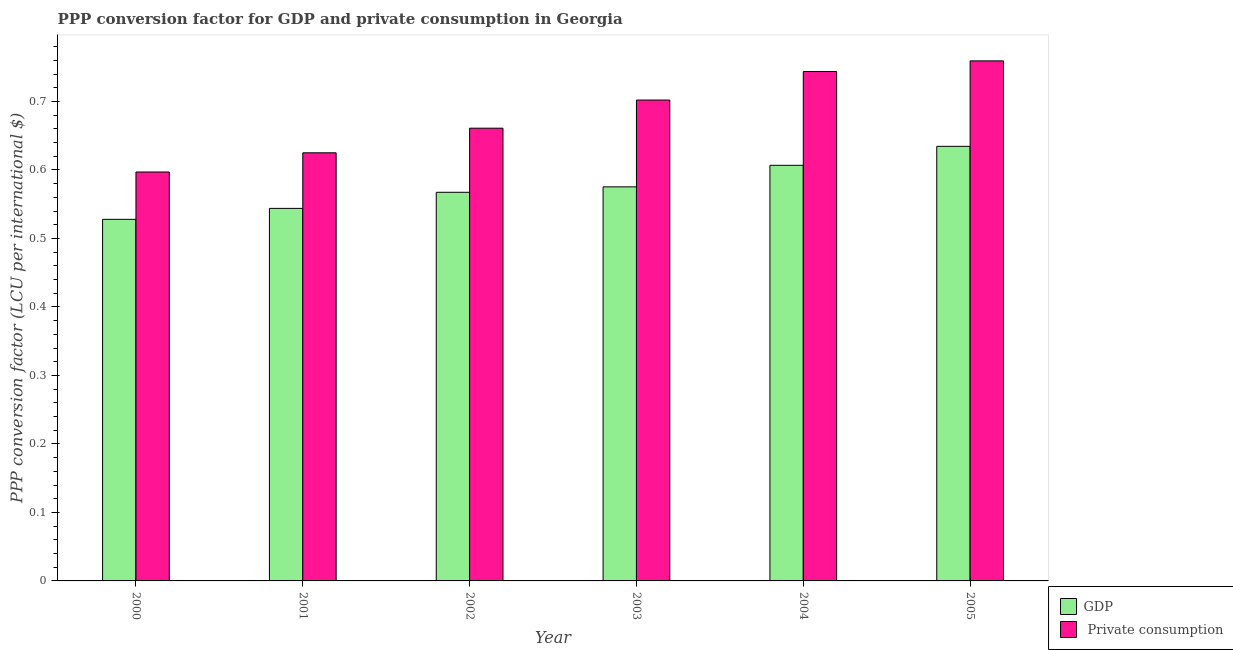How many groups of bars are there?
Ensure brevity in your answer.  6. How many bars are there on the 1st tick from the left?
Give a very brief answer. 2. What is the label of the 2nd group of bars from the left?
Your answer should be very brief. 2001. In how many cases, is the number of bars for a given year not equal to the number of legend labels?
Your response must be concise. 0. What is the ppp conversion factor for gdp in 2003?
Ensure brevity in your answer.  0.58. Across all years, what is the maximum ppp conversion factor for private consumption?
Provide a short and direct response. 0.76. Across all years, what is the minimum ppp conversion factor for gdp?
Provide a succinct answer. 0.53. In which year was the ppp conversion factor for private consumption minimum?
Your answer should be compact. 2000. What is the total ppp conversion factor for private consumption in the graph?
Make the answer very short. 4.09. What is the difference between the ppp conversion factor for gdp in 2002 and that in 2005?
Offer a terse response. -0.07. What is the difference between the ppp conversion factor for gdp in 2000 and the ppp conversion factor for private consumption in 2001?
Offer a terse response. -0.02. What is the average ppp conversion factor for gdp per year?
Ensure brevity in your answer.  0.58. In the year 2000, what is the difference between the ppp conversion factor for private consumption and ppp conversion factor for gdp?
Offer a very short reply. 0. What is the ratio of the ppp conversion factor for private consumption in 2001 to that in 2004?
Provide a short and direct response. 0.84. What is the difference between the highest and the second highest ppp conversion factor for private consumption?
Your answer should be compact. 0.02. What is the difference between the highest and the lowest ppp conversion factor for private consumption?
Offer a very short reply. 0.16. In how many years, is the ppp conversion factor for private consumption greater than the average ppp conversion factor for private consumption taken over all years?
Keep it short and to the point. 3. What does the 1st bar from the left in 2000 represents?
Offer a very short reply. GDP. What does the 1st bar from the right in 2002 represents?
Offer a terse response.  Private consumption. Are all the bars in the graph horizontal?
Ensure brevity in your answer.  No. What is the difference between two consecutive major ticks on the Y-axis?
Provide a short and direct response. 0.1. Are the values on the major ticks of Y-axis written in scientific E-notation?
Your answer should be very brief. No. Does the graph contain any zero values?
Your response must be concise. No. Where does the legend appear in the graph?
Make the answer very short. Bottom right. How are the legend labels stacked?
Your response must be concise. Vertical. What is the title of the graph?
Your answer should be compact. PPP conversion factor for GDP and private consumption in Georgia. Does "Arms imports" appear as one of the legend labels in the graph?
Provide a short and direct response. No. What is the label or title of the X-axis?
Offer a terse response. Year. What is the label or title of the Y-axis?
Your answer should be compact. PPP conversion factor (LCU per international $). What is the PPP conversion factor (LCU per international $) of GDP in 2000?
Make the answer very short. 0.53. What is the PPP conversion factor (LCU per international $) of  Private consumption in 2000?
Make the answer very short. 0.6. What is the PPP conversion factor (LCU per international $) of GDP in 2001?
Provide a succinct answer. 0.54. What is the PPP conversion factor (LCU per international $) in  Private consumption in 2001?
Keep it short and to the point. 0.63. What is the PPP conversion factor (LCU per international $) of GDP in 2002?
Offer a terse response. 0.57. What is the PPP conversion factor (LCU per international $) of  Private consumption in 2002?
Provide a short and direct response. 0.66. What is the PPP conversion factor (LCU per international $) of GDP in 2003?
Give a very brief answer. 0.58. What is the PPP conversion factor (LCU per international $) in  Private consumption in 2003?
Offer a terse response. 0.7. What is the PPP conversion factor (LCU per international $) in GDP in 2004?
Your answer should be compact. 0.61. What is the PPP conversion factor (LCU per international $) of  Private consumption in 2004?
Offer a very short reply. 0.74. What is the PPP conversion factor (LCU per international $) of GDP in 2005?
Your answer should be very brief. 0.63. What is the PPP conversion factor (LCU per international $) of  Private consumption in 2005?
Keep it short and to the point. 0.76. Across all years, what is the maximum PPP conversion factor (LCU per international $) in GDP?
Make the answer very short. 0.63. Across all years, what is the maximum PPP conversion factor (LCU per international $) of  Private consumption?
Your answer should be compact. 0.76. Across all years, what is the minimum PPP conversion factor (LCU per international $) in GDP?
Offer a very short reply. 0.53. Across all years, what is the minimum PPP conversion factor (LCU per international $) in  Private consumption?
Keep it short and to the point. 0.6. What is the total PPP conversion factor (LCU per international $) in GDP in the graph?
Ensure brevity in your answer.  3.46. What is the total PPP conversion factor (LCU per international $) in  Private consumption in the graph?
Offer a very short reply. 4.09. What is the difference between the PPP conversion factor (LCU per international $) in GDP in 2000 and that in 2001?
Provide a succinct answer. -0.02. What is the difference between the PPP conversion factor (LCU per international $) of  Private consumption in 2000 and that in 2001?
Provide a succinct answer. -0.03. What is the difference between the PPP conversion factor (LCU per international $) of GDP in 2000 and that in 2002?
Keep it short and to the point. -0.04. What is the difference between the PPP conversion factor (LCU per international $) of  Private consumption in 2000 and that in 2002?
Offer a very short reply. -0.06. What is the difference between the PPP conversion factor (LCU per international $) in GDP in 2000 and that in 2003?
Offer a terse response. -0.05. What is the difference between the PPP conversion factor (LCU per international $) of  Private consumption in 2000 and that in 2003?
Ensure brevity in your answer.  -0.1. What is the difference between the PPP conversion factor (LCU per international $) of GDP in 2000 and that in 2004?
Ensure brevity in your answer.  -0.08. What is the difference between the PPP conversion factor (LCU per international $) in  Private consumption in 2000 and that in 2004?
Offer a terse response. -0.15. What is the difference between the PPP conversion factor (LCU per international $) in GDP in 2000 and that in 2005?
Provide a succinct answer. -0.11. What is the difference between the PPP conversion factor (LCU per international $) of  Private consumption in 2000 and that in 2005?
Give a very brief answer. -0.16. What is the difference between the PPP conversion factor (LCU per international $) in GDP in 2001 and that in 2002?
Your answer should be very brief. -0.02. What is the difference between the PPP conversion factor (LCU per international $) in  Private consumption in 2001 and that in 2002?
Your response must be concise. -0.04. What is the difference between the PPP conversion factor (LCU per international $) in GDP in 2001 and that in 2003?
Ensure brevity in your answer.  -0.03. What is the difference between the PPP conversion factor (LCU per international $) in  Private consumption in 2001 and that in 2003?
Keep it short and to the point. -0.08. What is the difference between the PPP conversion factor (LCU per international $) in GDP in 2001 and that in 2004?
Offer a terse response. -0.06. What is the difference between the PPP conversion factor (LCU per international $) of  Private consumption in 2001 and that in 2004?
Make the answer very short. -0.12. What is the difference between the PPP conversion factor (LCU per international $) in GDP in 2001 and that in 2005?
Give a very brief answer. -0.09. What is the difference between the PPP conversion factor (LCU per international $) in  Private consumption in 2001 and that in 2005?
Offer a terse response. -0.13. What is the difference between the PPP conversion factor (LCU per international $) of GDP in 2002 and that in 2003?
Give a very brief answer. -0.01. What is the difference between the PPP conversion factor (LCU per international $) in  Private consumption in 2002 and that in 2003?
Offer a terse response. -0.04. What is the difference between the PPP conversion factor (LCU per international $) of GDP in 2002 and that in 2004?
Offer a very short reply. -0.04. What is the difference between the PPP conversion factor (LCU per international $) in  Private consumption in 2002 and that in 2004?
Offer a terse response. -0.08. What is the difference between the PPP conversion factor (LCU per international $) in GDP in 2002 and that in 2005?
Keep it short and to the point. -0.07. What is the difference between the PPP conversion factor (LCU per international $) in  Private consumption in 2002 and that in 2005?
Offer a very short reply. -0.1. What is the difference between the PPP conversion factor (LCU per international $) in GDP in 2003 and that in 2004?
Keep it short and to the point. -0.03. What is the difference between the PPP conversion factor (LCU per international $) of  Private consumption in 2003 and that in 2004?
Make the answer very short. -0.04. What is the difference between the PPP conversion factor (LCU per international $) in GDP in 2003 and that in 2005?
Provide a succinct answer. -0.06. What is the difference between the PPP conversion factor (LCU per international $) in  Private consumption in 2003 and that in 2005?
Ensure brevity in your answer.  -0.06. What is the difference between the PPP conversion factor (LCU per international $) in GDP in 2004 and that in 2005?
Give a very brief answer. -0.03. What is the difference between the PPP conversion factor (LCU per international $) in  Private consumption in 2004 and that in 2005?
Make the answer very short. -0.02. What is the difference between the PPP conversion factor (LCU per international $) of GDP in 2000 and the PPP conversion factor (LCU per international $) of  Private consumption in 2001?
Your answer should be compact. -0.1. What is the difference between the PPP conversion factor (LCU per international $) in GDP in 2000 and the PPP conversion factor (LCU per international $) in  Private consumption in 2002?
Your answer should be very brief. -0.13. What is the difference between the PPP conversion factor (LCU per international $) of GDP in 2000 and the PPP conversion factor (LCU per international $) of  Private consumption in 2003?
Give a very brief answer. -0.17. What is the difference between the PPP conversion factor (LCU per international $) of GDP in 2000 and the PPP conversion factor (LCU per international $) of  Private consumption in 2004?
Your answer should be very brief. -0.22. What is the difference between the PPP conversion factor (LCU per international $) in GDP in 2000 and the PPP conversion factor (LCU per international $) in  Private consumption in 2005?
Keep it short and to the point. -0.23. What is the difference between the PPP conversion factor (LCU per international $) of GDP in 2001 and the PPP conversion factor (LCU per international $) of  Private consumption in 2002?
Provide a short and direct response. -0.12. What is the difference between the PPP conversion factor (LCU per international $) of GDP in 2001 and the PPP conversion factor (LCU per international $) of  Private consumption in 2003?
Offer a terse response. -0.16. What is the difference between the PPP conversion factor (LCU per international $) of GDP in 2001 and the PPP conversion factor (LCU per international $) of  Private consumption in 2004?
Keep it short and to the point. -0.2. What is the difference between the PPP conversion factor (LCU per international $) of GDP in 2001 and the PPP conversion factor (LCU per international $) of  Private consumption in 2005?
Your answer should be compact. -0.22. What is the difference between the PPP conversion factor (LCU per international $) of GDP in 2002 and the PPP conversion factor (LCU per international $) of  Private consumption in 2003?
Offer a very short reply. -0.13. What is the difference between the PPP conversion factor (LCU per international $) in GDP in 2002 and the PPP conversion factor (LCU per international $) in  Private consumption in 2004?
Give a very brief answer. -0.18. What is the difference between the PPP conversion factor (LCU per international $) of GDP in 2002 and the PPP conversion factor (LCU per international $) of  Private consumption in 2005?
Offer a terse response. -0.19. What is the difference between the PPP conversion factor (LCU per international $) in GDP in 2003 and the PPP conversion factor (LCU per international $) in  Private consumption in 2004?
Offer a very short reply. -0.17. What is the difference between the PPP conversion factor (LCU per international $) in GDP in 2003 and the PPP conversion factor (LCU per international $) in  Private consumption in 2005?
Your answer should be compact. -0.18. What is the difference between the PPP conversion factor (LCU per international $) of GDP in 2004 and the PPP conversion factor (LCU per international $) of  Private consumption in 2005?
Offer a terse response. -0.15. What is the average PPP conversion factor (LCU per international $) in GDP per year?
Your answer should be very brief. 0.58. What is the average PPP conversion factor (LCU per international $) of  Private consumption per year?
Provide a short and direct response. 0.68. In the year 2000, what is the difference between the PPP conversion factor (LCU per international $) of GDP and PPP conversion factor (LCU per international $) of  Private consumption?
Give a very brief answer. -0.07. In the year 2001, what is the difference between the PPP conversion factor (LCU per international $) in GDP and PPP conversion factor (LCU per international $) in  Private consumption?
Provide a succinct answer. -0.08. In the year 2002, what is the difference between the PPP conversion factor (LCU per international $) of GDP and PPP conversion factor (LCU per international $) of  Private consumption?
Ensure brevity in your answer.  -0.09. In the year 2003, what is the difference between the PPP conversion factor (LCU per international $) in GDP and PPP conversion factor (LCU per international $) in  Private consumption?
Give a very brief answer. -0.13. In the year 2004, what is the difference between the PPP conversion factor (LCU per international $) of GDP and PPP conversion factor (LCU per international $) of  Private consumption?
Offer a very short reply. -0.14. In the year 2005, what is the difference between the PPP conversion factor (LCU per international $) of GDP and PPP conversion factor (LCU per international $) of  Private consumption?
Make the answer very short. -0.12. What is the ratio of the PPP conversion factor (LCU per international $) in GDP in 2000 to that in 2001?
Provide a succinct answer. 0.97. What is the ratio of the PPP conversion factor (LCU per international $) in  Private consumption in 2000 to that in 2001?
Provide a succinct answer. 0.96. What is the ratio of the PPP conversion factor (LCU per international $) of GDP in 2000 to that in 2002?
Keep it short and to the point. 0.93. What is the ratio of the PPP conversion factor (LCU per international $) of  Private consumption in 2000 to that in 2002?
Your answer should be compact. 0.9. What is the ratio of the PPP conversion factor (LCU per international $) in GDP in 2000 to that in 2003?
Your answer should be very brief. 0.92. What is the ratio of the PPP conversion factor (LCU per international $) in  Private consumption in 2000 to that in 2003?
Your answer should be very brief. 0.85. What is the ratio of the PPP conversion factor (LCU per international $) of GDP in 2000 to that in 2004?
Provide a short and direct response. 0.87. What is the ratio of the PPP conversion factor (LCU per international $) in  Private consumption in 2000 to that in 2004?
Ensure brevity in your answer.  0.8. What is the ratio of the PPP conversion factor (LCU per international $) in GDP in 2000 to that in 2005?
Provide a short and direct response. 0.83. What is the ratio of the PPP conversion factor (LCU per international $) of  Private consumption in 2000 to that in 2005?
Offer a terse response. 0.79. What is the ratio of the PPP conversion factor (LCU per international $) of GDP in 2001 to that in 2002?
Provide a short and direct response. 0.96. What is the ratio of the PPP conversion factor (LCU per international $) of  Private consumption in 2001 to that in 2002?
Provide a short and direct response. 0.95. What is the ratio of the PPP conversion factor (LCU per international $) in GDP in 2001 to that in 2003?
Provide a succinct answer. 0.95. What is the ratio of the PPP conversion factor (LCU per international $) in  Private consumption in 2001 to that in 2003?
Offer a very short reply. 0.89. What is the ratio of the PPP conversion factor (LCU per international $) of GDP in 2001 to that in 2004?
Your answer should be very brief. 0.9. What is the ratio of the PPP conversion factor (LCU per international $) of  Private consumption in 2001 to that in 2004?
Your answer should be very brief. 0.84. What is the ratio of the PPP conversion factor (LCU per international $) in GDP in 2001 to that in 2005?
Give a very brief answer. 0.86. What is the ratio of the PPP conversion factor (LCU per international $) in  Private consumption in 2001 to that in 2005?
Your answer should be very brief. 0.82. What is the ratio of the PPP conversion factor (LCU per international $) in GDP in 2002 to that in 2003?
Offer a very short reply. 0.99. What is the ratio of the PPP conversion factor (LCU per international $) of  Private consumption in 2002 to that in 2003?
Offer a very short reply. 0.94. What is the ratio of the PPP conversion factor (LCU per international $) of GDP in 2002 to that in 2004?
Give a very brief answer. 0.94. What is the ratio of the PPP conversion factor (LCU per international $) in  Private consumption in 2002 to that in 2004?
Your answer should be compact. 0.89. What is the ratio of the PPP conversion factor (LCU per international $) in GDP in 2002 to that in 2005?
Your answer should be compact. 0.89. What is the ratio of the PPP conversion factor (LCU per international $) of  Private consumption in 2002 to that in 2005?
Your answer should be compact. 0.87. What is the ratio of the PPP conversion factor (LCU per international $) in GDP in 2003 to that in 2004?
Ensure brevity in your answer.  0.95. What is the ratio of the PPP conversion factor (LCU per international $) of  Private consumption in 2003 to that in 2004?
Give a very brief answer. 0.94. What is the ratio of the PPP conversion factor (LCU per international $) in GDP in 2003 to that in 2005?
Keep it short and to the point. 0.91. What is the ratio of the PPP conversion factor (LCU per international $) in  Private consumption in 2003 to that in 2005?
Make the answer very short. 0.92. What is the ratio of the PPP conversion factor (LCU per international $) of GDP in 2004 to that in 2005?
Keep it short and to the point. 0.96. What is the ratio of the PPP conversion factor (LCU per international $) of  Private consumption in 2004 to that in 2005?
Your answer should be very brief. 0.98. What is the difference between the highest and the second highest PPP conversion factor (LCU per international $) of GDP?
Offer a very short reply. 0.03. What is the difference between the highest and the second highest PPP conversion factor (LCU per international $) in  Private consumption?
Your answer should be very brief. 0.02. What is the difference between the highest and the lowest PPP conversion factor (LCU per international $) in GDP?
Your response must be concise. 0.11. What is the difference between the highest and the lowest PPP conversion factor (LCU per international $) of  Private consumption?
Your response must be concise. 0.16. 